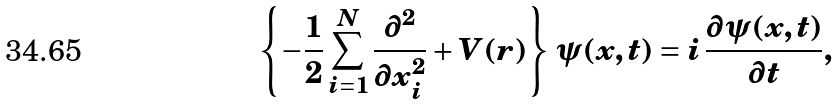Convert formula to latex. <formula><loc_0><loc_0><loc_500><loc_500>\left \{ - \frac { 1 } { 2 } \sum _ { i = 1 } ^ { N } \frac { \partial ^ { 2 } } { \partial x _ { i } ^ { 2 } } + V ( r ) \right \} \, \psi ( x , t ) = i \, \frac { \partial \psi ( x , t ) } { \partial t } ,</formula> 